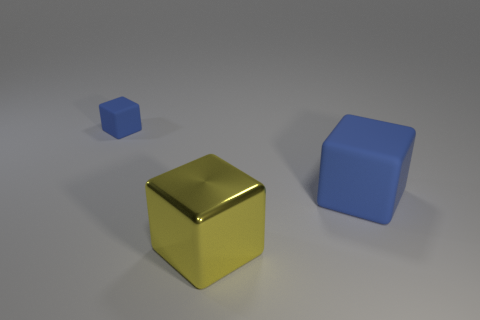Add 1 blue metal cubes. How many objects exist? 4 Subtract all tiny blue blocks. How many blocks are left? 2 Subtract all yellow blocks. How many blocks are left? 2 Subtract 1 blocks. How many blocks are left? 2 Subtract 0 purple blocks. How many objects are left? 3 Subtract all purple cubes. Subtract all blue spheres. How many cubes are left? 3 Subtract all brown balls. How many brown cubes are left? 0 Subtract all red shiny cylinders. Subtract all large yellow cubes. How many objects are left? 2 Add 1 rubber blocks. How many rubber blocks are left? 3 Add 1 big blue blocks. How many big blue blocks exist? 2 